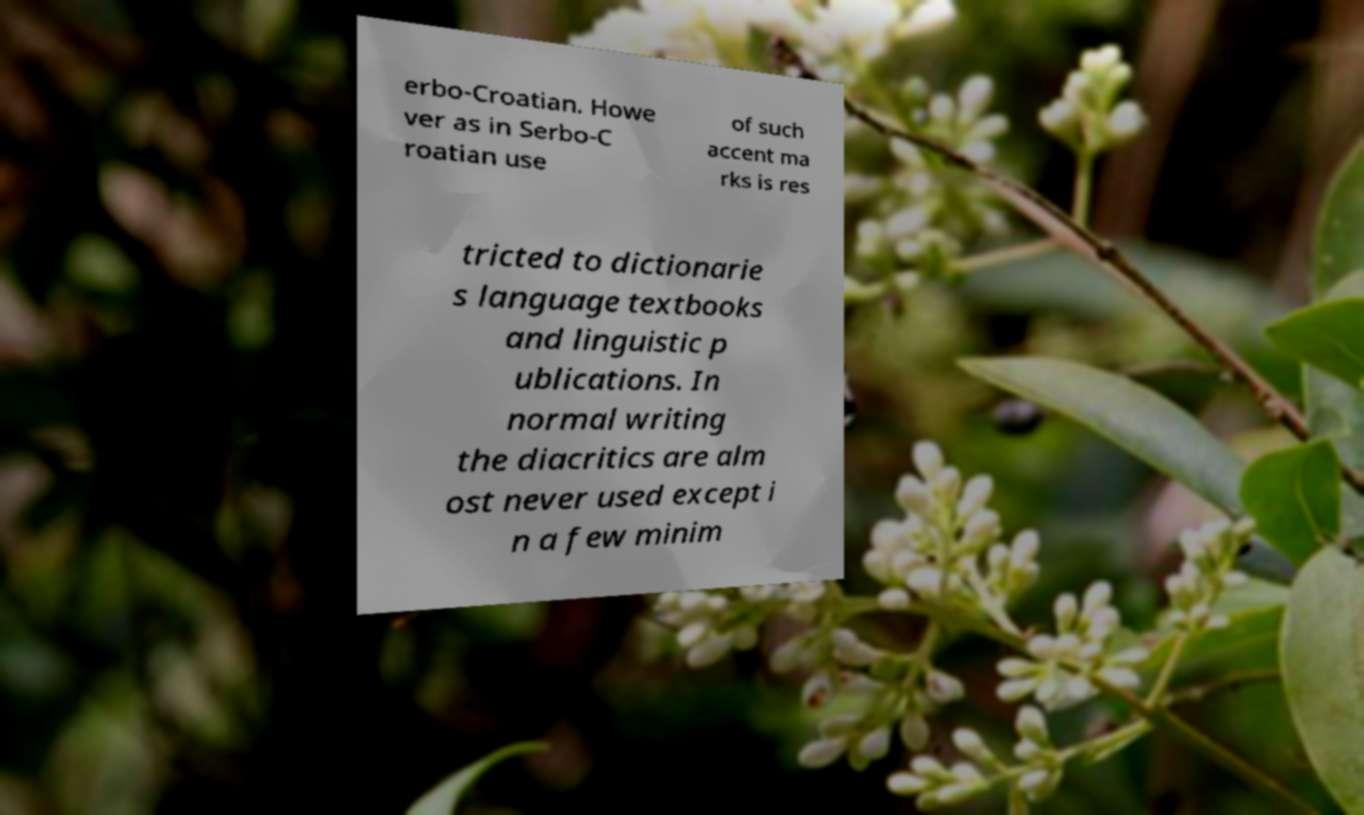Can you accurately transcribe the text from the provided image for me? erbo-Croatian. Howe ver as in Serbo-C roatian use of such accent ma rks is res tricted to dictionarie s language textbooks and linguistic p ublications. In normal writing the diacritics are alm ost never used except i n a few minim 